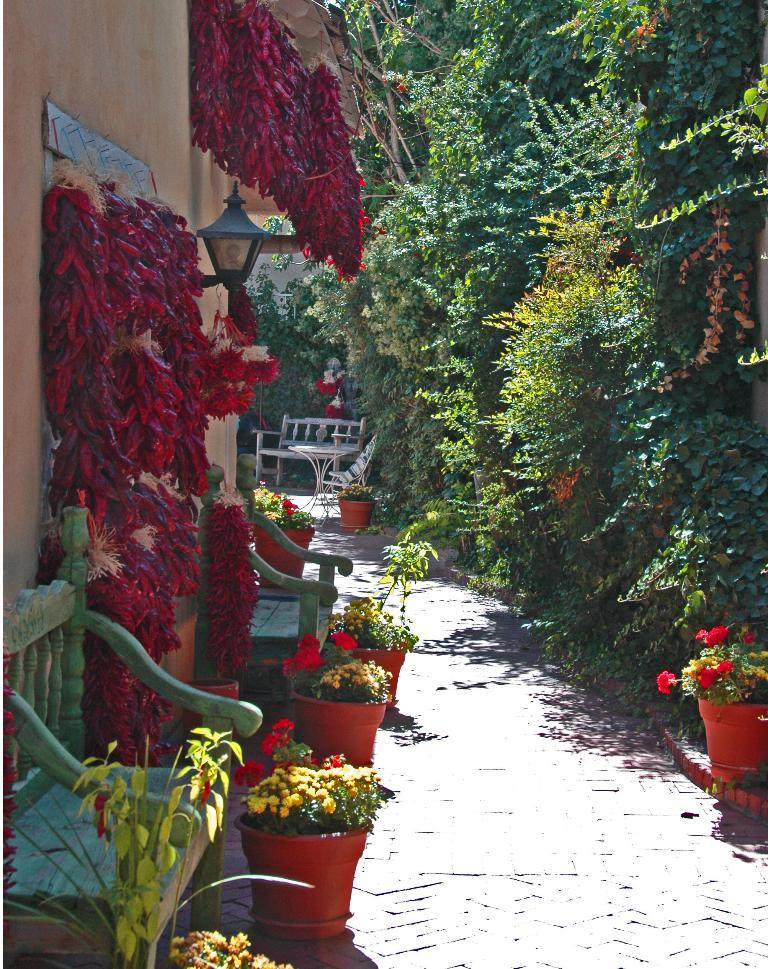What type of furniture is present in the image? There are chairs in the image. What is on the ground in the image? There are house plants with flowers on the ground. What can be seen in the background of the image? There is a wall, a light, a table, a bench, and trees in the background of the image. Can you see friends smoking near the ocean in the image? There are no friends, smoke, or ocean present in the image. 